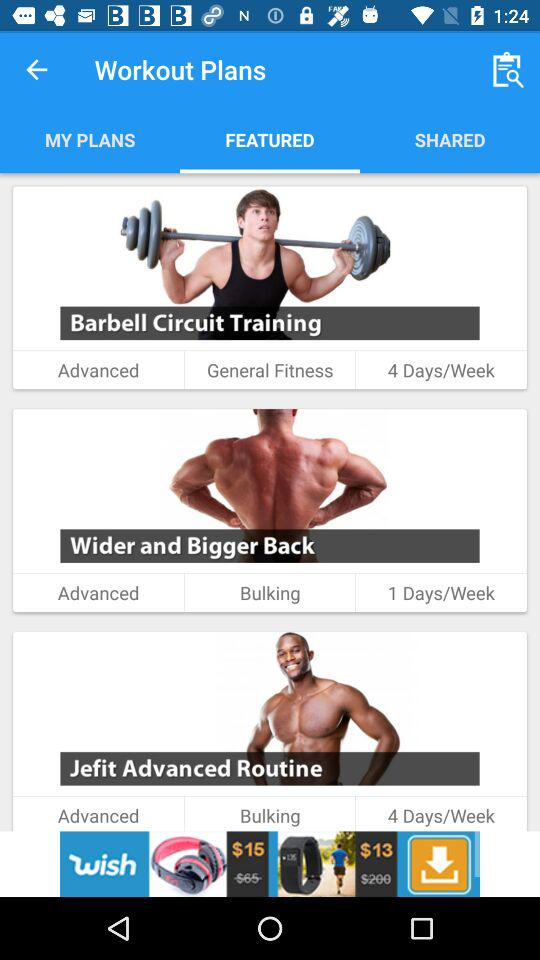How many days per week do you have to do the "Barbell Circuit Training"? "Barbell Circuit Training" needs to be done 4 days per week. 